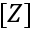Convert formula to latex. <formula><loc_0><loc_0><loc_500><loc_500>[ Z ]</formula> 